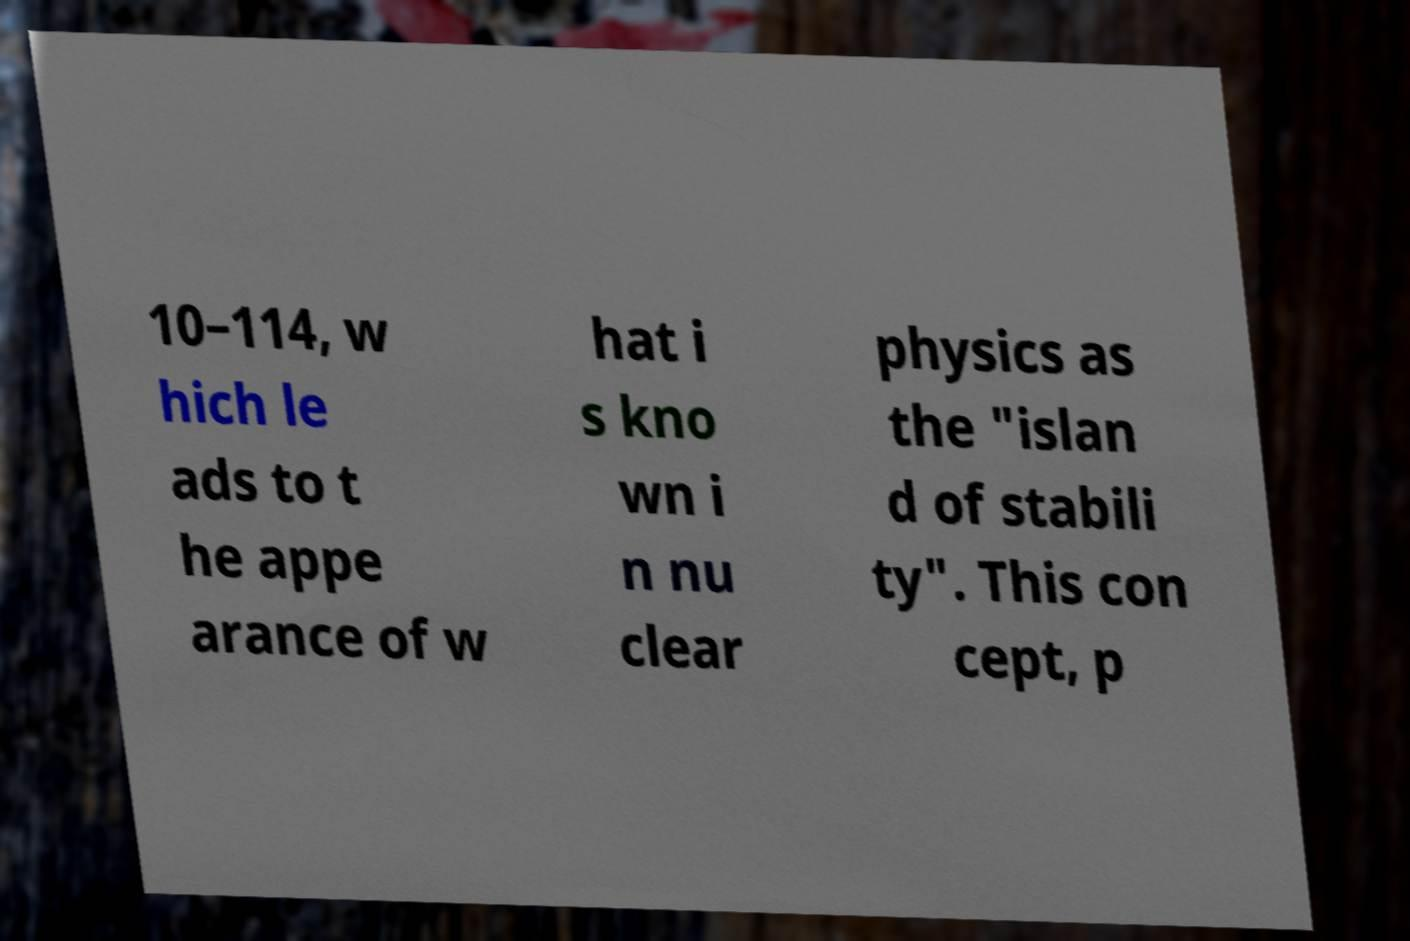There's text embedded in this image that I need extracted. Can you transcribe it verbatim? 10–114, w hich le ads to t he appe arance of w hat i s kno wn i n nu clear physics as the "islan d of stabili ty". This con cept, p 